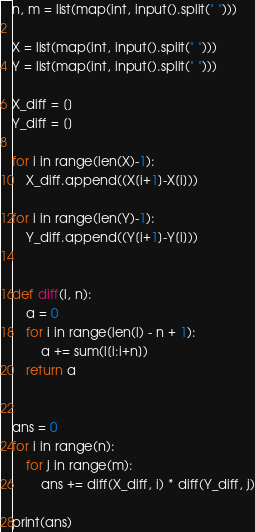<code> <loc_0><loc_0><loc_500><loc_500><_Python_>n, m = list(map(int, input().split(" ")))

X = list(map(int, input().split(" ")))
Y = list(map(int, input().split(" ")))

X_diff = []
Y_diff = []

for i in range(len(X)-1):
    X_diff.append((X[i+1]-X[i]))
                  
for i in range(len(Y)-1):
    Y_diff.append((Y[i+1]-Y[i]))
    
    
def diff(l, n):
    a = 0
    for i in range(len(l) - n + 1):
        a += sum(l[i:i+n])
    return a

    
ans = 0
for i in range(n):
    for j in range(m):
        ans += diff(X_diff, i) * diff(Y_diff, j)
        
print(ans)</code> 